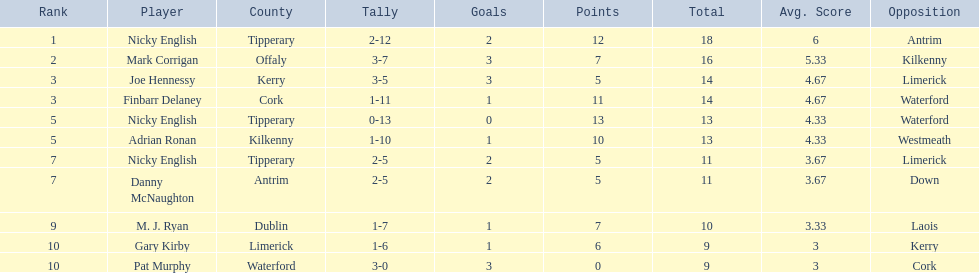What was the average of the totals of nicky english and mark corrigan? 17. 